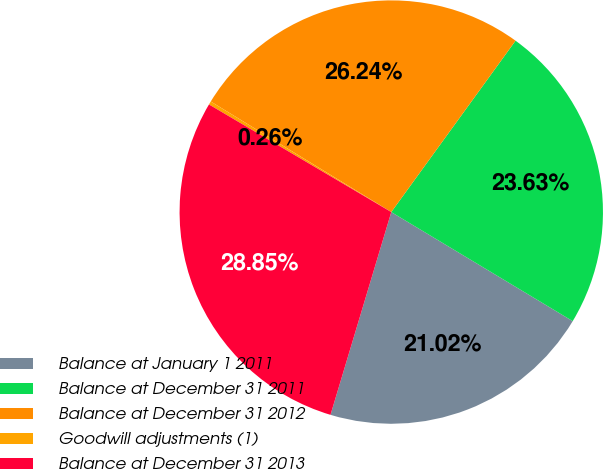<chart> <loc_0><loc_0><loc_500><loc_500><pie_chart><fcel>Balance at January 1 2011<fcel>Balance at December 31 2011<fcel>Balance at December 31 2012<fcel>Goodwill adjustments (1)<fcel>Balance at December 31 2013<nl><fcel>21.02%<fcel>23.63%<fcel>26.24%<fcel>0.26%<fcel>28.85%<nl></chart> 